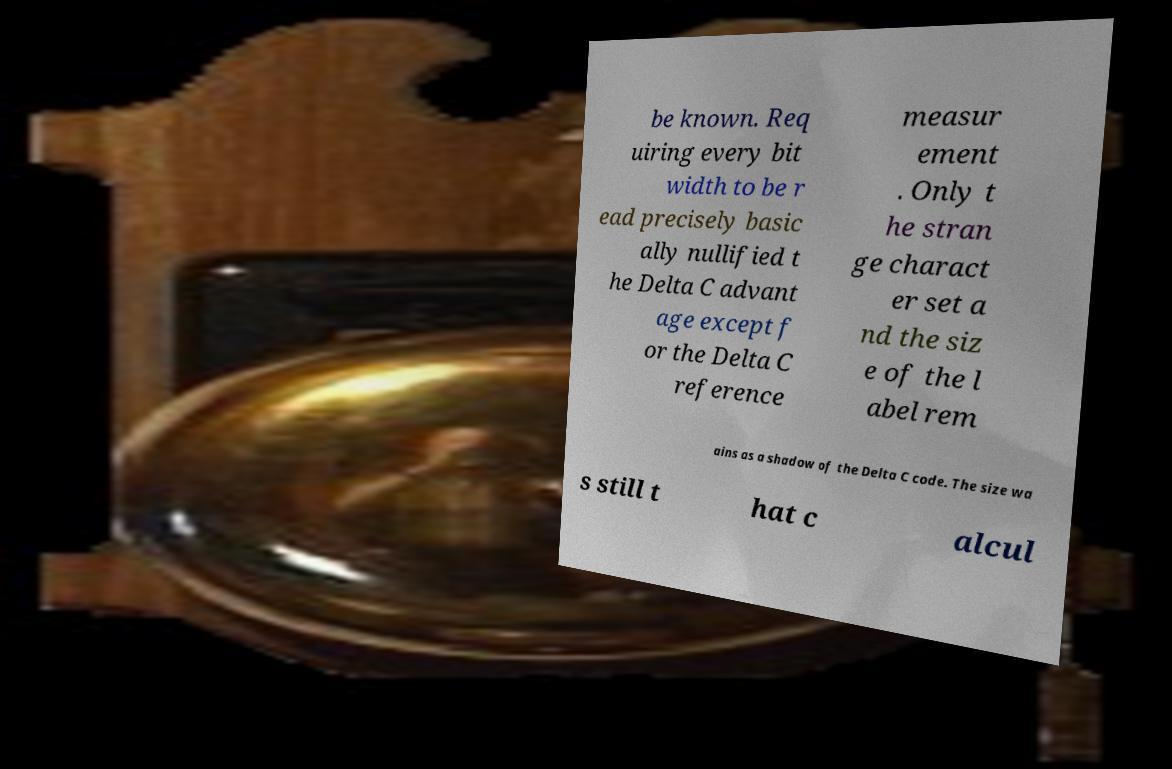There's text embedded in this image that I need extracted. Can you transcribe it verbatim? be known. Req uiring every bit width to be r ead precisely basic ally nullified t he Delta C advant age except f or the Delta C reference measur ement . Only t he stran ge charact er set a nd the siz e of the l abel rem ains as a shadow of the Delta C code. The size wa s still t hat c alcul 